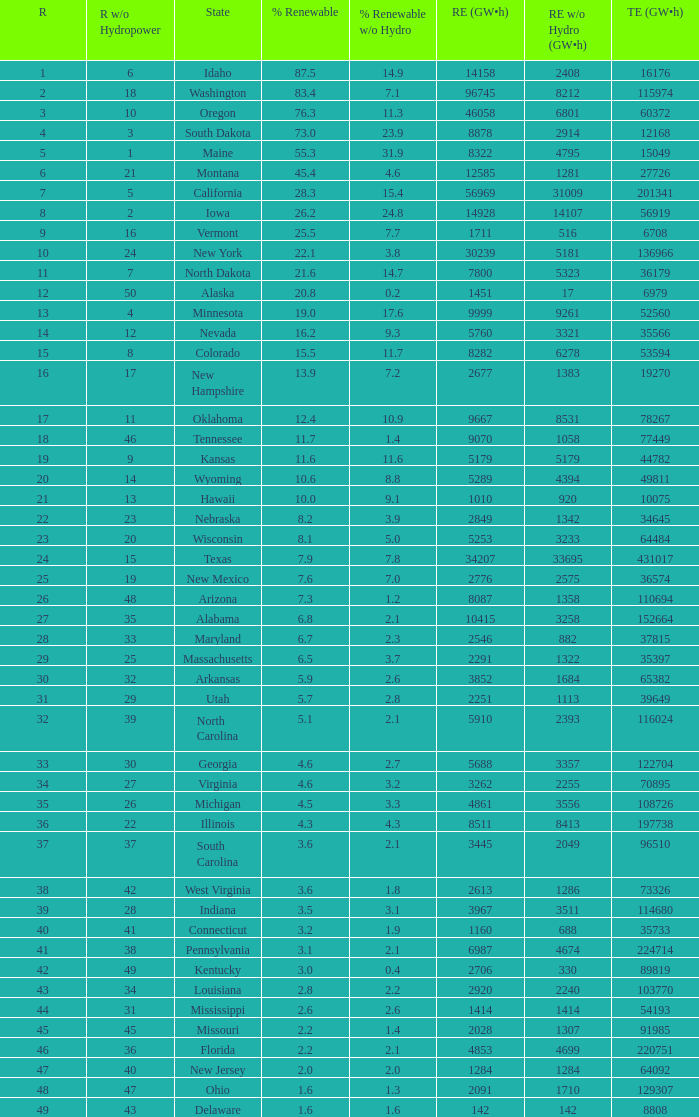What is the maximum renewable energy (gw×h) for the state of Delaware? 142.0. 